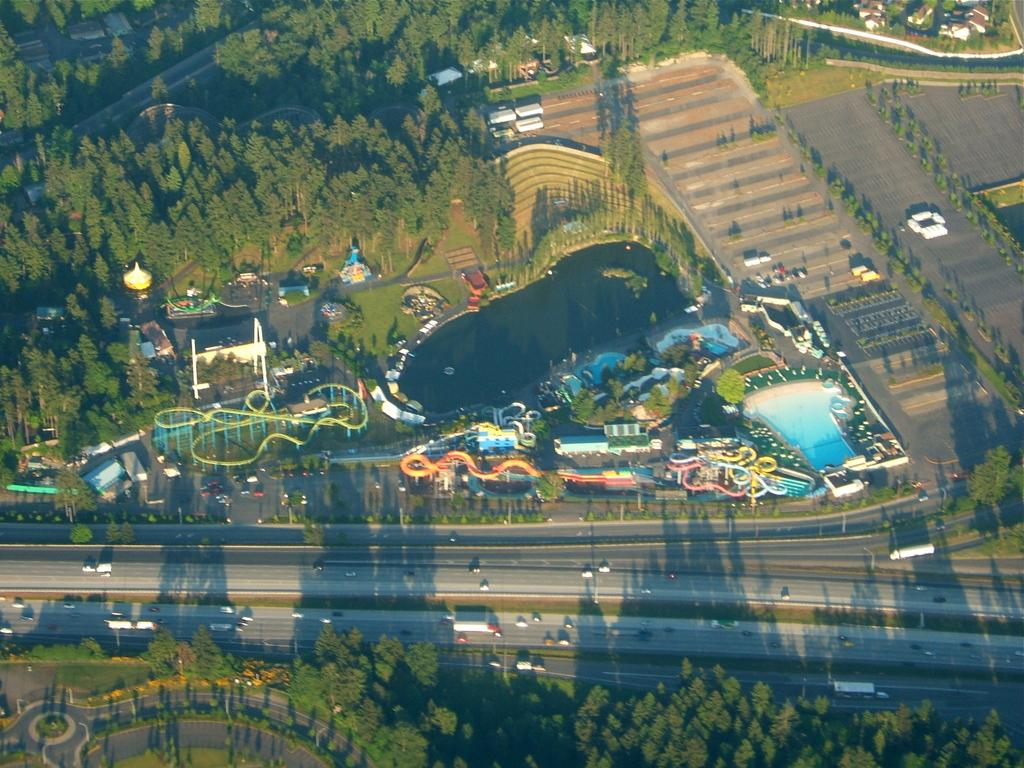What type of view is provided in the image? The image is an aerial view. What natural elements can be seen in the image? There are trees, grassy land, and plants visible in the image. What man-made structures or features can be seen in the image? Vehicles, rides, a swimming pool, roads, and a pond are present in the image. What type of twig is being used to control the swimming pool in the image? There is no twig present in the image, and no indication that the swimming pool is being controlled by any object. 